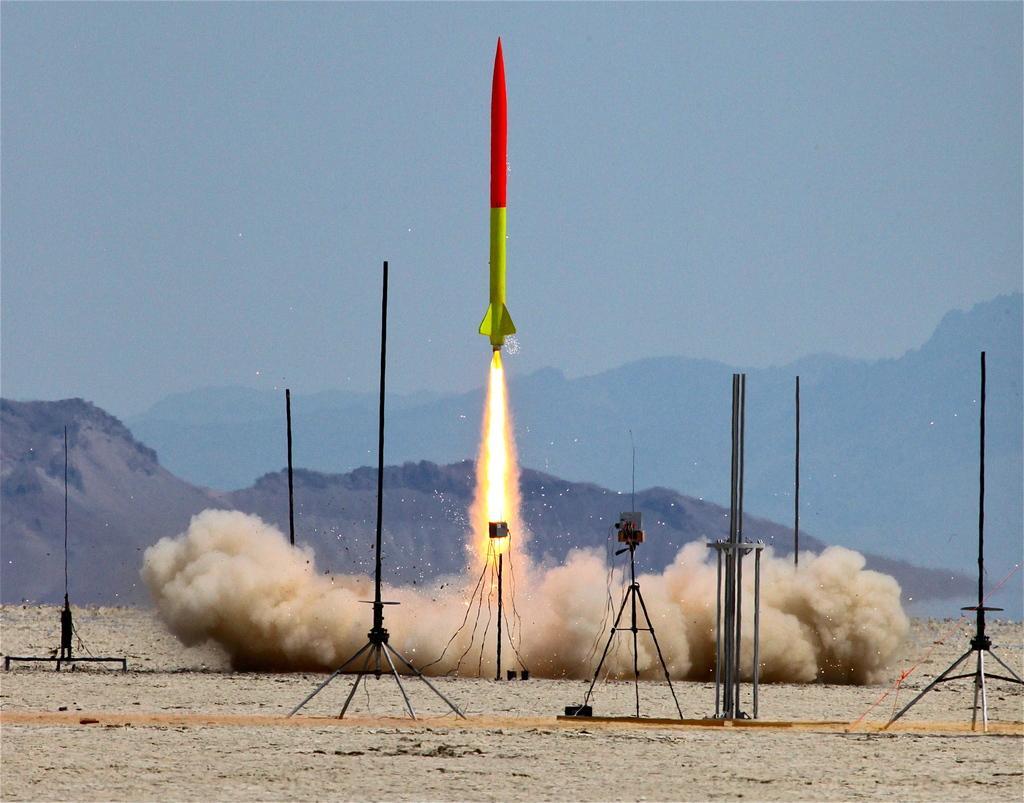Can you describe this image briefly? This picture shows a missile emitting fire and we see few metal stands and hills and a cloudy Sky. 